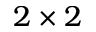<formula> <loc_0><loc_0><loc_500><loc_500>2 \times 2</formula> 